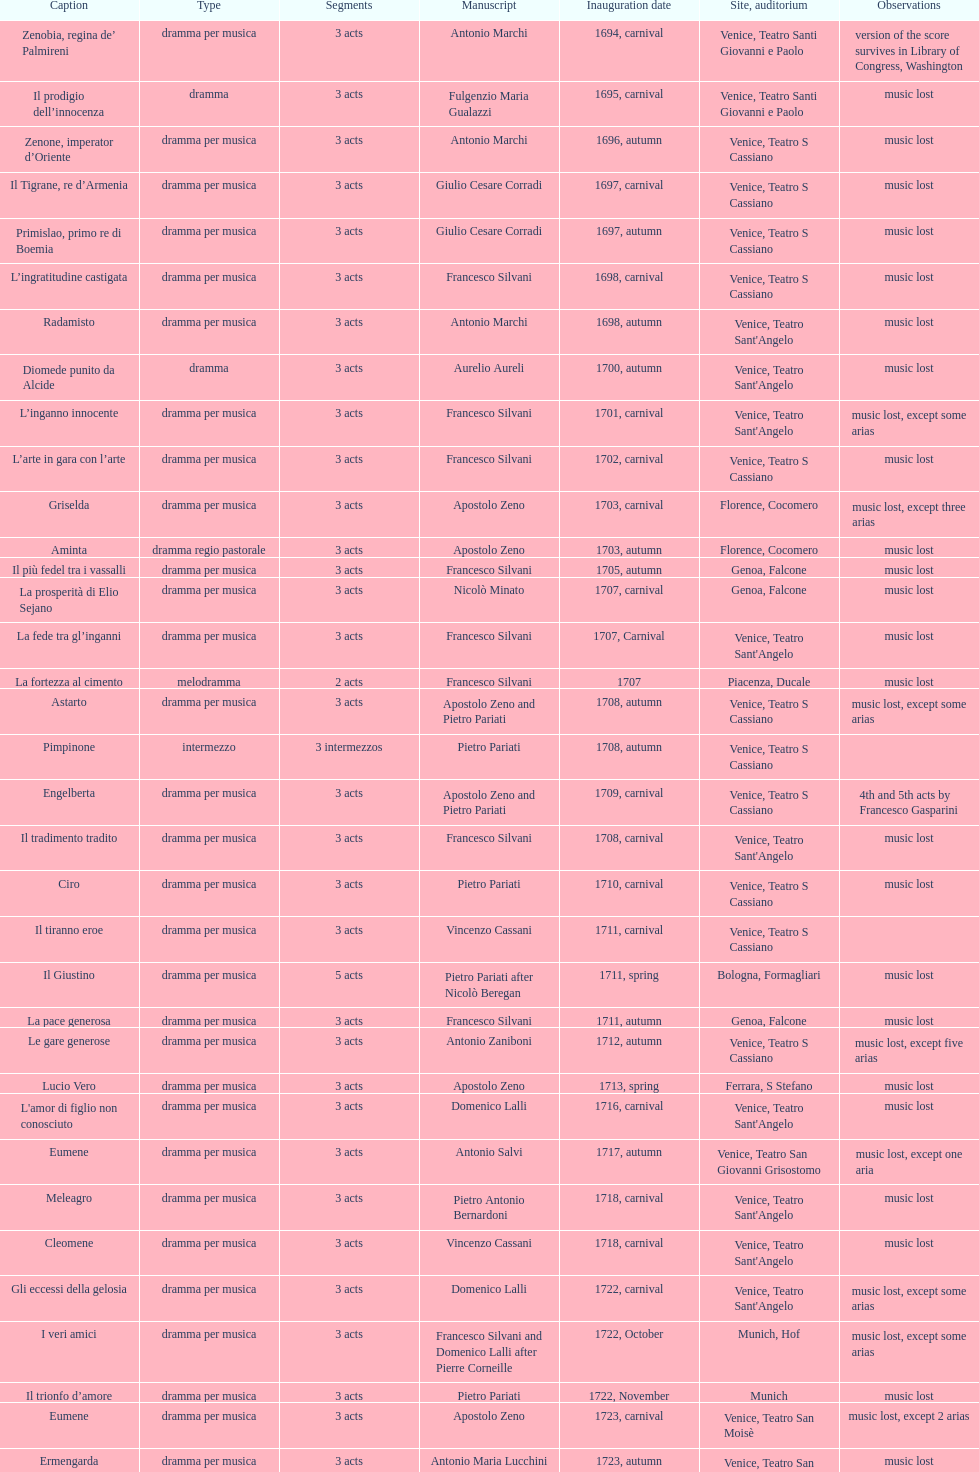Which title premiered directly after candalide? Artamene. 